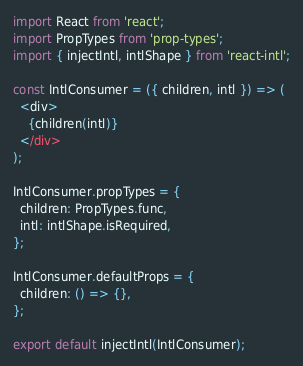Convert code to text. <code><loc_0><loc_0><loc_500><loc_500><_JavaScript_>import React from 'react';
import PropTypes from 'prop-types';
import { injectIntl, intlShape } from 'react-intl';

const IntlConsumer = ({ children, intl }) => (
  <div>
    {children(intl)}
  </div>
);

IntlConsumer.propTypes = {
  children: PropTypes.func,
  intl: intlShape.isRequired,
};

IntlConsumer.defaultProps = {
  children: () => {},
};

export default injectIntl(IntlConsumer);
</code> 